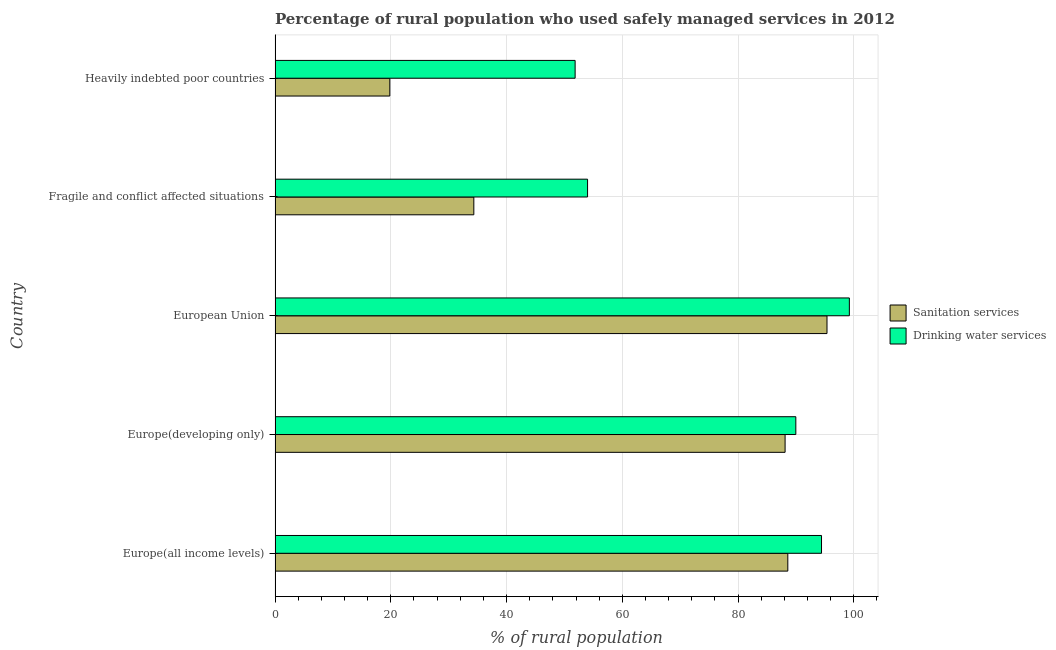How many different coloured bars are there?
Provide a succinct answer. 2. Are the number of bars per tick equal to the number of legend labels?
Give a very brief answer. Yes. How many bars are there on the 1st tick from the bottom?
Provide a succinct answer. 2. What is the label of the 4th group of bars from the top?
Give a very brief answer. Europe(developing only). In how many cases, is the number of bars for a given country not equal to the number of legend labels?
Ensure brevity in your answer.  0. What is the percentage of rural population who used sanitation services in Europe(all income levels)?
Give a very brief answer. 88.6. Across all countries, what is the maximum percentage of rural population who used drinking water services?
Your response must be concise. 99.23. Across all countries, what is the minimum percentage of rural population who used drinking water services?
Your answer should be compact. 51.85. In which country was the percentage of rural population who used sanitation services maximum?
Give a very brief answer. European Union. In which country was the percentage of rural population who used sanitation services minimum?
Give a very brief answer. Heavily indebted poor countries. What is the total percentage of rural population who used sanitation services in the graph?
Your response must be concise. 326.26. What is the difference between the percentage of rural population who used sanitation services in Europe(all income levels) and that in Heavily indebted poor countries?
Keep it short and to the point. 68.77. What is the difference between the percentage of rural population who used sanitation services in Europe(all income levels) and the percentage of rural population who used drinking water services in Fragile and conflict affected situations?
Offer a terse response. 34.6. What is the average percentage of rural population who used drinking water services per country?
Your response must be concise. 77.89. What is the difference between the percentage of rural population who used sanitation services and percentage of rural population who used drinking water services in European Union?
Your answer should be very brief. -3.86. What is the ratio of the percentage of rural population who used drinking water services in Europe(all income levels) to that in Fragile and conflict affected situations?
Make the answer very short. 1.75. Is the percentage of rural population who used drinking water services in Europe(developing only) less than that in Heavily indebted poor countries?
Your answer should be compact. No. What is the difference between the highest and the second highest percentage of rural population who used drinking water services?
Your response must be concise. 4.81. What is the difference between the highest and the lowest percentage of rural population who used drinking water services?
Provide a succinct answer. 47.39. What does the 2nd bar from the top in Europe(developing only) represents?
Provide a short and direct response. Sanitation services. What does the 2nd bar from the bottom in Fragile and conflict affected situations represents?
Your response must be concise. Drinking water services. What is the difference between two consecutive major ticks on the X-axis?
Your answer should be very brief. 20. Are the values on the major ticks of X-axis written in scientific E-notation?
Offer a very short reply. No. Does the graph contain any zero values?
Your answer should be very brief. No. Where does the legend appear in the graph?
Give a very brief answer. Center right. How many legend labels are there?
Offer a very short reply. 2. How are the legend labels stacked?
Keep it short and to the point. Vertical. What is the title of the graph?
Make the answer very short. Percentage of rural population who used safely managed services in 2012. What is the label or title of the X-axis?
Keep it short and to the point. % of rural population. What is the % of rural population of Sanitation services in Europe(all income levels)?
Your response must be concise. 88.6. What is the % of rural population in Drinking water services in Europe(all income levels)?
Your response must be concise. 94.42. What is the % of rural population in Sanitation services in Europe(developing only)?
Give a very brief answer. 88.13. What is the % of rural population in Drinking water services in Europe(developing only)?
Provide a succinct answer. 89.98. What is the % of rural population of Sanitation services in European Union?
Your answer should be very brief. 95.37. What is the % of rural population in Drinking water services in European Union?
Make the answer very short. 99.23. What is the % of rural population in Sanitation services in Fragile and conflict affected situations?
Your response must be concise. 34.34. What is the % of rural population in Drinking water services in Fragile and conflict affected situations?
Your answer should be very brief. 53.99. What is the % of rural population in Sanitation services in Heavily indebted poor countries?
Ensure brevity in your answer.  19.82. What is the % of rural population in Drinking water services in Heavily indebted poor countries?
Your answer should be very brief. 51.85. Across all countries, what is the maximum % of rural population of Sanitation services?
Your response must be concise. 95.37. Across all countries, what is the maximum % of rural population of Drinking water services?
Keep it short and to the point. 99.23. Across all countries, what is the minimum % of rural population in Sanitation services?
Your answer should be very brief. 19.82. Across all countries, what is the minimum % of rural population of Drinking water services?
Provide a short and direct response. 51.85. What is the total % of rural population in Sanitation services in the graph?
Offer a very short reply. 326.26. What is the total % of rural population of Drinking water services in the graph?
Your response must be concise. 389.48. What is the difference between the % of rural population of Sanitation services in Europe(all income levels) and that in Europe(developing only)?
Ensure brevity in your answer.  0.47. What is the difference between the % of rural population of Drinking water services in Europe(all income levels) and that in Europe(developing only)?
Your response must be concise. 4.44. What is the difference between the % of rural population of Sanitation services in Europe(all income levels) and that in European Union?
Keep it short and to the point. -6.77. What is the difference between the % of rural population of Drinking water services in Europe(all income levels) and that in European Union?
Your answer should be very brief. -4.81. What is the difference between the % of rural population of Sanitation services in Europe(all income levels) and that in Fragile and conflict affected situations?
Make the answer very short. 54.25. What is the difference between the % of rural population of Drinking water services in Europe(all income levels) and that in Fragile and conflict affected situations?
Your answer should be compact. 40.43. What is the difference between the % of rural population in Sanitation services in Europe(all income levels) and that in Heavily indebted poor countries?
Your answer should be compact. 68.77. What is the difference between the % of rural population in Drinking water services in Europe(all income levels) and that in Heavily indebted poor countries?
Keep it short and to the point. 42.57. What is the difference between the % of rural population of Sanitation services in Europe(developing only) and that in European Union?
Your response must be concise. -7.24. What is the difference between the % of rural population of Drinking water services in Europe(developing only) and that in European Union?
Provide a short and direct response. -9.25. What is the difference between the % of rural population of Sanitation services in Europe(developing only) and that in Fragile and conflict affected situations?
Provide a short and direct response. 53.79. What is the difference between the % of rural population of Drinking water services in Europe(developing only) and that in Fragile and conflict affected situations?
Your answer should be very brief. 35.99. What is the difference between the % of rural population in Sanitation services in Europe(developing only) and that in Heavily indebted poor countries?
Provide a succinct answer. 68.3. What is the difference between the % of rural population of Drinking water services in Europe(developing only) and that in Heavily indebted poor countries?
Ensure brevity in your answer.  38.14. What is the difference between the % of rural population of Sanitation services in European Union and that in Fragile and conflict affected situations?
Give a very brief answer. 61.02. What is the difference between the % of rural population of Drinking water services in European Union and that in Fragile and conflict affected situations?
Ensure brevity in your answer.  45.24. What is the difference between the % of rural population of Sanitation services in European Union and that in Heavily indebted poor countries?
Ensure brevity in your answer.  75.54. What is the difference between the % of rural population of Drinking water services in European Union and that in Heavily indebted poor countries?
Your response must be concise. 47.39. What is the difference between the % of rural population of Sanitation services in Fragile and conflict affected situations and that in Heavily indebted poor countries?
Offer a terse response. 14.52. What is the difference between the % of rural population in Drinking water services in Fragile and conflict affected situations and that in Heavily indebted poor countries?
Keep it short and to the point. 2.15. What is the difference between the % of rural population in Sanitation services in Europe(all income levels) and the % of rural population in Drinking water services in Europe(developing only)?
Give a very brief answer. -1.39. What is the difference between the % of rural population in Sanitation services in Europe(all income levels) and the % of rural population in Drinking water services in European Union?
Make the answer very short. -10.63. What is the difference between the % of rural population in Sanitation services in Europe(all income levels) and the % of rural population in Drinking water services in Fragile and conflict affected situations?
Provide a short and direct response. 34.6. What is the difference between the % of rural population in Sanitation services in Europe(all income levels) and the % of rural population in Drinking water services in Heavily indebted poor countries?
Offer a terse response. 36.75. What is the difference between the % of rural population of Sanitation services in Europe(developing only) and the % of rural population of Drinking water services in European Union?
Keep it short and to the point. -11.1. What is the difference between the % of rural population in Sanitation services in Europe(developing only) and the % of rural population in Drinking water services in Fragile and conflict affected situations?
Make the answer very short. 34.13. What is the difference between the % of rural population of Sanitation services in Europe(developing only) and the % of rural population of Drinking water services in Heavily indebted poor countries?
Offer a terse response. 36.28. What is the difference between the % of rural population in Sanitation services in European Union and the % of rural population in Drinking water services in Fragile and conflict affected situations?
Keep it short and to the point. 41.37. What is the difference between the % of rural population of Sanitation services in European Union and the % of rural population of Drinking water services in Heavily indebted poor countries?
Provide a short and direct response. 43.52. What is the difference between the % of rural population of Sanitation services in Fragile and conflict affected situations and the % of rural population of Drinking water services in Heavily indebted poor countries?
Ensure brevity in your answer.  -17.5. What is the average % of rural population of Sanitation services per country?
Provide a short and direct response. 65.25. What is the average % of rural population of Drinking water services per country?
Make the answer very short. 77.9. What is the difference between the % of rural population of Sanitation services and % of rural population of Drinking water services in Europe(all income levels)?
Your answer should be compact. -5.82. What is the difference between the % of rural population in Sanitation services and % of rural population in Drinking water services in Europe(developing only)?
Keep it short and to the point. -1.85. What is the difference between the % of rural population of Sanitation services and % of rural population of Drinking water services in European Union?
Offer a terse response. -3.86. What is the difference between the % of rural population in Sanitation services and % of rural population in Drinking water services in Fragile and conflict affected situations?
Give a very brief answer. -19.65. What is the difference between the % of rural population of Sanitation services and % of rural population of Drinking water services in Heavily indebted poor countries?
Your answer should be very brief. -32.02. What is the ratio of the % of rural population of Sanitation services in Europe(all income levels) to that in Europe(developing only)?
Provide a short and direct response. 1.01. What is the ratio of the % of rural population in Drinking water services in Europe(all income levels) to that in Europe(developing only)?
Your response must be concise. 1.05. What is the ratio of the % of rural population of Sanitation services in Europe(all income levels) to that in European Union?
Offer a terse response. 0.93. What is the ratio of the % of rural population of Drinking water services in Europe(all income levels) to that in European Union?
Keep it short and to the point. 0.95. What is the ratio of the % of rural population of Sanitation services in Europe(all income levels) to that in Fragile and conflict affected situations?
Keep it short and to the point. 2.58. What is the ratio of the % of rural population in Drinking water services in Europe(all income levels) to that in Fragile and conflict affected situations?
Provide a succinct answer. 1.75. What is the ratio of the % of rural population in Sanitation services in Europe(all income levels) to that in Heavily indebted poor countries?
Offer a terse response. 4.47. What is the ratio of the % of rural population in Drinking water services in Europe(all income levels) to that in Heavily indebted poor countries?
Offer a terse response. 1.82. What is the ratio of the % of rural population of Sanitation services in Europe(developing only) to that in European Union?
Offer a very short reply. 0.92. What is the ratio of the % of rural population of Drinking water services in Europe(developing only) to that in European Union?
Offer a very short reply. 0.91. What is the ratio of the % of rural population of Sanitation services in Europe(developing only) to that in Fragile and conflict affected situations?
Make the answer very short. 2.57. What is the ratio of the % of rural population of Drinking water services in Europe(developing only) to that in Fragile and conflict affected situations?
Your answer should be very brief. 1.67. What is the ratio of the % of rural population of Sanitation services in Europe(developing only) to that in Heavily indebted poor countries?
Ensure brevity in your answer.  4.45. What is the ratio of the % of rural population of Drinking water services in Europe(developing only) to that in Heavily indebted poor countries?
Your answer should be very brief. 1.74. What is the ratio of the % of rural population of Sanitation services in European Union to that in Fragile and conflict affected situations?
Offer a terse response. 2.78. What is the ratio of the % of rural population in Drinking water services in European Union to that in Fragile and conflict affected situations?
Give a very brief answer. 1.84. What is the ratio of the % of rural population in Sanitation services in European Union to that in Heavily indebted poor countries?
Provide a short and direct response. 4.81. What is the ratio of the % of rural population of Drinking water services in European Union to that in Heavily indebted poor countries?
Provide a short and direct response. 1.91. What is the ratio of the % of rural population of Sanitation services in Fragile and conflict affected situations to that in Heavily indebted poor countries?
Your response must be concise. 1.73. What is the ratio of the % of rural population in Drinking water services in Fragile and conflict affected situations to that in Heavily indebted poor countries?
Provide a succinct answer. 1.04. What is the difference between the highest and the second highest % of rural population of Sanitation services?
Offer a very short reply. 6.77. What is the difference between the highest and the second highest % of rural population in Drinking water services?
Offer a terse response. 4.81. What is the difference between the highest and the lowest % of rural population of Sanitation services?
Provide a short and direct response. 75.54. What is the difference between the highest and the lowest % of rural population in Drinking water services?
Keep it short and to the point. 47.39. 